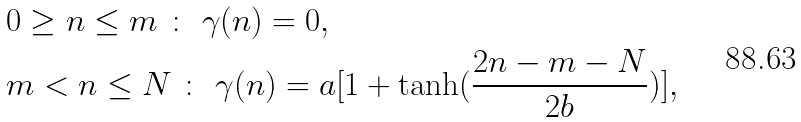Convert formula to latex. <formula><loc_0><loc_0><loc_500><loc_500>& 0 \geq n \leq m \ \colon \ \gamma ( n ) = 0 , \\ & m < n \leq N \ \colon \ \gamma ( n ) = a [ 1 + \tanh ( \frac { 2 n - m - N } { 2 b } ) ] ,</formula> 